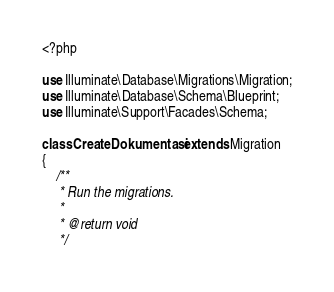Convert code to text. <code><loc_0><loc_0><loc_500><loc_500><_PHP_><?php

use Illuminate\Database\Migrations\Migration;
use Illuminate\Database\Schema\Blueprint;
use Illuminate\Support\Facades\Schema;

class CreateDokumentasi extends Migration
{
    /**
     * Run the migrations.
     *
     * @return void
     */</code> 